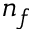<formula> <loc_0><loc_0><loc_500><loc_500>n _ { f }</formula> 